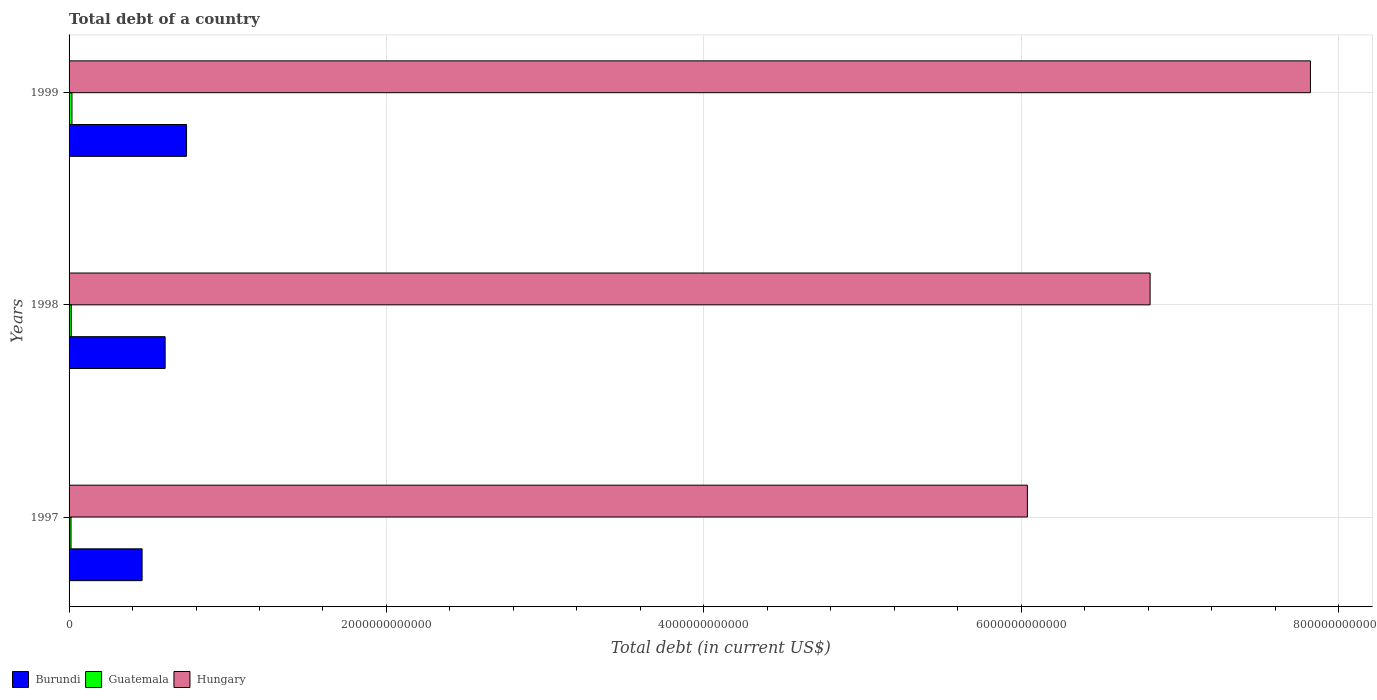Are the number of bars per tick equal to the number of legend labels?
Your response must be concise. Yes. What is the label of the 1st group of bars from the top?
Your answer should be very brief. 1999. What is the debt in Guatemala in 1999?
Ensure brevity in your answer.  1.82e+1. Across all years, what is the maximum debt in Burundi?
Your answer should be compact. 7.40e+11. Across all years, what is the minimum debt in Hungary?
Offer a terse response. 6.04e+12. What is the total debt in Guatemala in the graph?
Make the answer very short. 4.45e+1. What is the difference between the debt in Guatemala in 1997 and that in 1999?
Provide a succinct answer. -5.98e+09. What is the difference between the debt in Burundi in 1998 and the debt in Hungary in 1999?
Give a very brief answer. -7.22e+12. What is the average debt in Hungary per year?
Offer a very short reply. 6.89e+12. In the year 1999, what is the difference between the debt in Guatemala and debt in Hungary?
Your answer should be compact. -7.80e+12. What is the ratio of the debt in Guatemala in 1997 to that in 1999?
Your response must be concise. 0.67. Is the debt in Burundi in 1997 less than that in 1999?
Provide a succinct answer. Yes. What is the difference between the highest and the second highest debt in Hungary?
Offer a very short reply. 1.01e+12. What is the difference between the highest and the lowest debt in Burundi?
Provide a short and direct response. 2.80e+11. In how many years, is the debt in Hungary greater than the average debt in Hungary taken over all years?
Make the answer very short. 1. What does the 1st bar from the top in 1999 represents?
Offer a terse response. Hungary. What does the 1st bar from the bottom in 1998 represents?
Your answer should be very brief. Burundi. Is it the case that in every year, the sum of the debt in Guatemala and debt in Hungary is greater than the debt in Burundi?
Provide a succinct answer. Yes. How many bars are there?
Provide a short and direct response. 9. How many years are there in the graph?
Make the answer very short. 3. What is the difference between two consecutive major ticks on the X-axis?
Provide a succinct answer. 2.00e+12. Does the graph contain any zero values?
Your answer should be compact. No. Where does the legend appear in the graph?
Keep it short and to the point. Bottom left. How many legend labels are there?
Your answer should be compact. 3. What is the title of the graph?
Your answer should be compact. Total debt of a country. Does "OECD members" appear as one of the legend labels in the graph?
Provide a succinct answer. No. What is the label or title of the X-axis?
Provide a succinct answer. Total debt (in current US$). What is the Total debt (in current US$) in Burundi in 1997?
Keep it short and to the point. 4.60e+11. What is the Total debt (in current US$) of Guatemala in 1997?
Give a very brief answer. 1.22e+1. What is the Total debt (in current US$) in Hungary in 1997?
Your answer should be very brief. 6.04e+12. What is the Total debt (in current US$) of Burundi in 1998?
Make the answer very short. 6.05e+11. What is the Total debt (in current US$) in Guatemala in 1998?
Provide a succinct answer. 1.40e+1. What is the Total debt (in current US$) of Hungary in 1998?
Offer a terse response. 6.81e+12. What is the Total debt (in current US$) in Burundi in 1999?
Your response must be concise. 7.40e+11. What is the Total debt (in current US$) of Guatemala in 1999?
Offer a terse response. 1.82e+1. What is the Total debt (in current US$) of Hungary in 1999?
Keep it short and to the point. 7.82e+12. Across all years, what is the maximum Total debt (in current US$) of Burundi?
Offer a very short reply. 7.40e+11. Across all years, what is the maximum Total debt (in current US$) in Guatemala?
Offer a terse response. 1.82e+1. Across all years, what is the maximum Total debt (in current US$) of Hungary?
Your answer should be very brief. 7.82e+12. Across all years, what is the minimum Total debt (in current US$) in Burundi?
Your answer should be very brief. 4.60e+11. Across all years, what is the minimum Total debt (in current US$) of Guatemala?
Make the answer very short. 1.22e+1. Across all years, what is the minimum Total debt (in current US$) of Hungary?
Your response must be concise. 6.04e+12. What is the total Total debt (in current US$) of Burundi in the graph?
Offer a very short reply. 1.81e+12. What is the total Total debt (in current US$) in Guatemala in the graph?
Offer a terse response. 4.45e+1. What is the total Total debt (in current US$) of Hungary in the graph?
Ensure brevity in your answer.  2.07e+13. What is the difference between the Total debt (in current US$) in Burundi in 1997 and that in 1998?
Your answer should be very brief. -1.45e+11. What is the difference between the Total debt (in current US$) of Guatemala in 1997 and that in 1998?
Offer a very short reply. -1.75e+09. What is the difference between the Total debt (in current US$) of Hungary in 1997 and that in 1998?
Keep it short and to the point. -7.73e+11. What is the difference between the Total debt (in current US$) of Burundi in 1997 and that in 1999?
Offer a very short reply. -2.80e+11. What is the difference between the Total debt (in current US$) in Guatemala in 1997 and that in 1999?
Provide a succinct answer. -5.98e+09. What is the difference between the Total debt (in current US$) in Hungary in 1997 and that in 1999?
Offer a terse response. -1.78e+12. What is the difference between the Total debt (in current US$) in Burundi in 1998 and that in 1999?
Your response must be concise. -1.35e+11. What is the difference between the Total debt (in current US$) of Guatemala in 1998 and that in 1999?
Provide a short and direct response. -4.23e+09. What is the difference between the Total debt (in current US$) in Hungary in 1998 and that in 1999?
Offer a very short reply. -1.01e+12. What is the difference between the Total debt (in current US$) in Burundi in 1997 and the Total debt (in current US$) in Guatemala in 1998?
Ensure brevity in your answer.  4.46e+11. What is the difference between the Total debt (in current US$) of Burundi in 1997 and the Total debt (in current US$) of Hungary in 1998?
Give a very brief answer. -6.35e+12. What is the difference between the Total debt (in current US$) of Guatemala in 1997 and the Total debt (in current US$) of Hungary in 1998?
Your response must be concise. -6.80e+12. What is the difference between the Total debt (in current US$) in Burundi in 1997 and the Total debt (in current US$) in Guatemala in 1999?
Your response must be concise. 4.42e+11. What is the difference between the Total debt (in current US$) of Burundi in 1997 and the Total debt (in current US$) of Hungary in 1999?
Offer a very short reply. -7.36e+12. What is the difference between the Total debt (in current US$) of Guatemala in 1997 and the Total debt (in current US$) of Hungary in 1999?
Provide a short and direct response. -7.81e+12. What is the difference between the Total debt (in current US$) of Burundi in 1998 and the Total debt (in current US$) of Guatemala in 1999?
Ensure brevity in your answer.  5.87e+11. What is the difference between the Total debt (in current US$) in Burundi in 1998 and the Total debt (in current US$) in Hungary in 1999?
Your answer should be very brief. -7.22e+12. What is the difference between the Total debt (in current US$) of Guatemala in 1998 and the Total debt (in current US$) of Hungary in 1999?
Keep it short and to the point. -7.81e+12. What is the average Total debt (in current US$) in Burundi per year?
Your response must be concise. 6.02e+11. What is the average Total debt (in current US$) in Guatemala per year?
Provide a short and direct response. 1.48e+1. What is the average Total debt (in current US$) in Hungary per year?
Keep it short and to the point. 6.89e+12. In the year 1997, what is the difference between the Total debt (in current US$) of Burundi and Total debt (in current US$) of Guatemala?
Your answer should be very brief. 4.48e+11. In the year 1997, what is the difference between the Total debt (in current US$) of Burundi and Total debt (in current US$) of Hungary?
Provide a short and direct response. -5.58e+12. In the year 1997, what is the difference between the Total debt (in current US$) of Guatemala and Total debt (in current US$) of Hungary?
Your answer should be compact. -6.03e+12. In the year 1998, what is the difference between the Total debt (in current US$) of Burundi and Total debt (in current US$) of Guatemala?
Make the answer very short. 5.91e+11. In the year 1998, what is the difference between the Total debt (in current US$) in Burundi and Total debt (in current US$) in Hungary?
Provide a short and direct response. -6.21e+12. In the year 1998, what is the difference between the Total debt (in current US$) of Guatemala and Total debt (in current US$) of Hungary?
Provide a short and direct response. -6.80e+12. In the year 1999, what is the difference between the Total debt (in current US$) in Burundi and Total debt (in current US$) in Guatemala?
Your response must be concise. 7.22e+11. In the year 1999, what is the difference between the Total debt (in current US$) of Burundi and Total debt (in current US$) of Hungary?
Offer a very short reply. -7.08e+12. In the year 1999, what is the difference between the Total debt (in current US$) of Guatemala and Total debt (in current US$) of Hungary?
Ensure brevity in your answer.  -7.80e+12. What is the ratio of the Total debt (in current US$) of Burundi in 1997 to that in 1998?
Ensure brevity in your answer.  0.76. What is the ratio of the Total debt (in current US$) of Guatemala in 1997 to that in 1998?
Keep it short and to the point. 0.87. What is the ratio of the Total debt (in current US$) in Hungary in 1997 to that in 1998?
Your answer should be compact. 0.89. What is the ratio of the Total debt (in current US$) of Burundi in 1997 to that in 1999?
Keep it short and to the point. 0.62. What is the ratio of the Total debt (in current US$) in Guatemala in 1997 to that in 1999?
Offer a terse response. 0.67. What is the ratio of the Total debt (in current US$) in Hungary in 1997 to that in 1999?
Your response must be concise. 0.77. What is the ratio of the Total debt (in current US$) of Burundi in 1998 to that in 1999?
Provide a succinct answer. 0.82. What is the ratio of the Total debt (in current US$) of Guatemala in 1998 to that in 1999?
Offer a terse response. 0.77. What is the ratio of the Total debt (in current US$) of Hungary in 1998 to that in 1999?
Make the answer very short. 0.87. What is the difference between the highest and the second highest Total debt (in current US$) of Burundi?
Keep it short and to the point. 1.35e+11. What is the difference between the highest and the second highest Total debt (in current US$) in Guatemala?
Offer a terse response. 4.23e+09. What is the difference between the highest and the second highest Total debt (in current US$) in Hungary?
Your answer should be very brief. 1.01e+12. What is the difference between the highest and the lowest Total debt (in current US$) of Burundi?
Provide a short and direct response. 2.80e+11. What is the difference between the highest and the lowest Total debt (in current US$) of Guatemala?
Your answer should be compact. 5.98e+09. What is the difference between the highest and the lowest Total debt (in current US$) of Hungary?
Ensure brevity in your answer.  1.78e+12. 